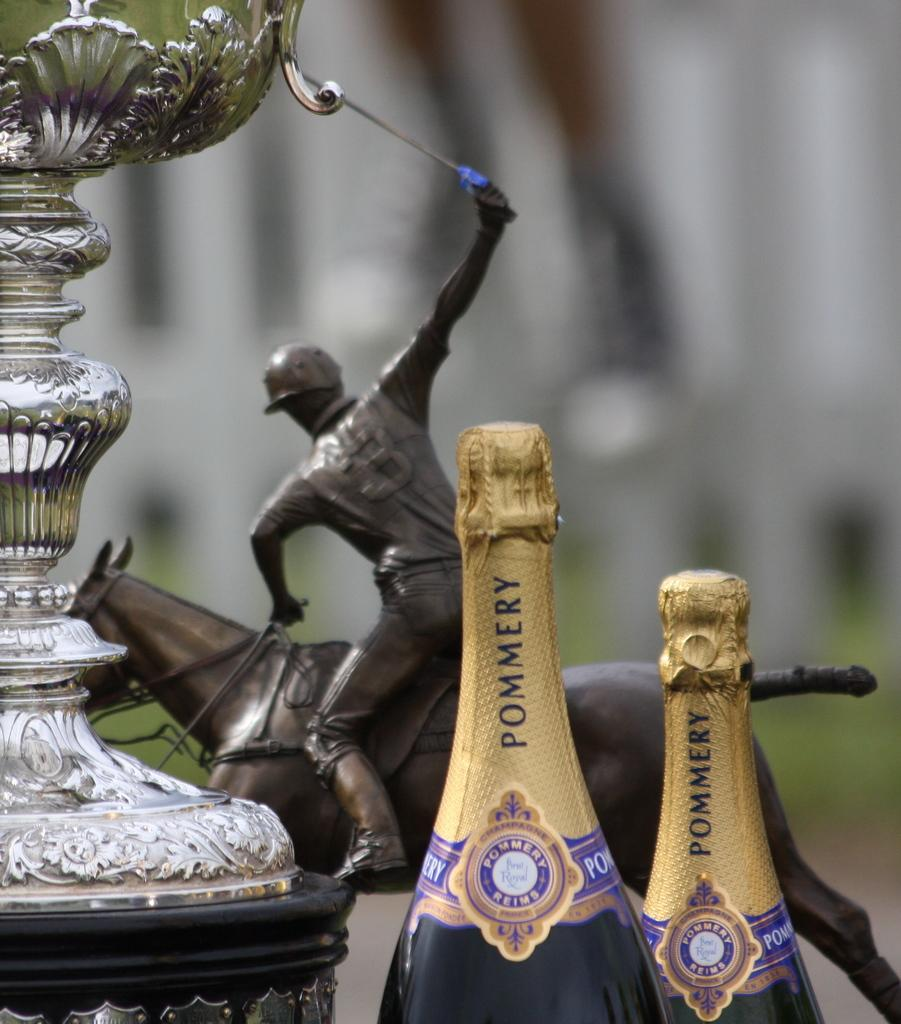What is the main subject of the image? There is a statue of a person on a horse in the image. What other objects can be seen in the image? There are bottles and an unspecified object in the image. Can you describe the background of the image? The background of the image is blurred. What level of experience does the beginner have with the jar in the image? There is no jar present in the image, and therefore no beginner or experience level can be determined. What story is being told by the statue in the image? The image does not provide any context or story about the statue; it simply depicts the statue itself. 